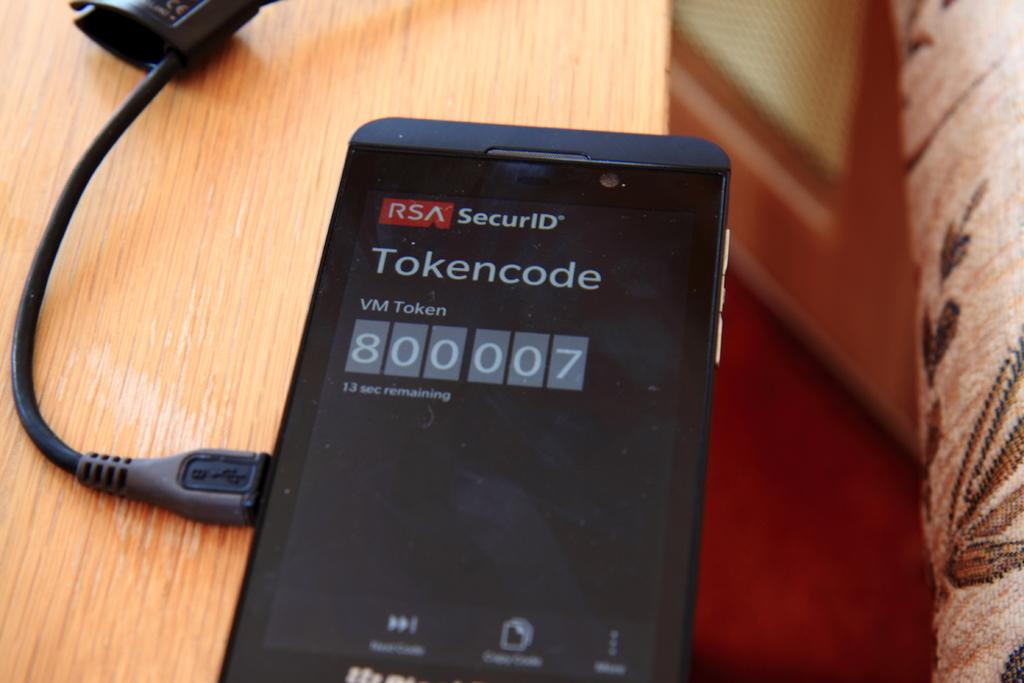<image>
Provide a brief description of the given image. a cell phone plugged into a charge with a tokencode displayed on the screen 